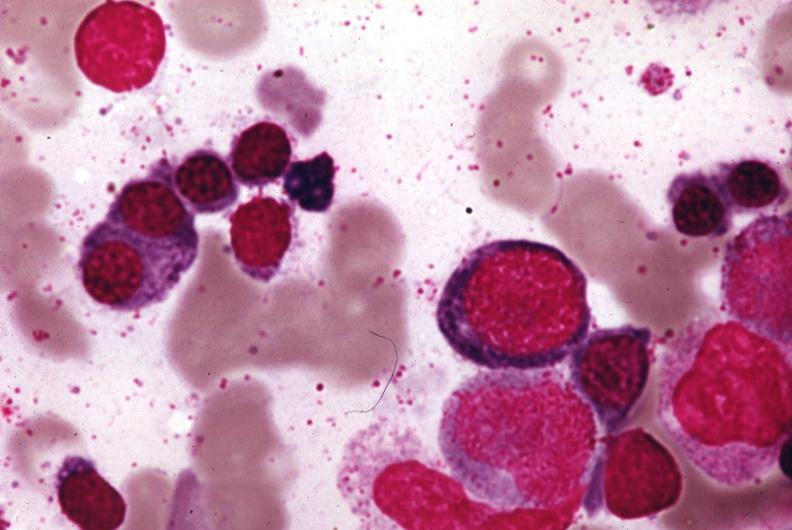s bone marrow present?
Answer the question using a single word or phrase. Yes 